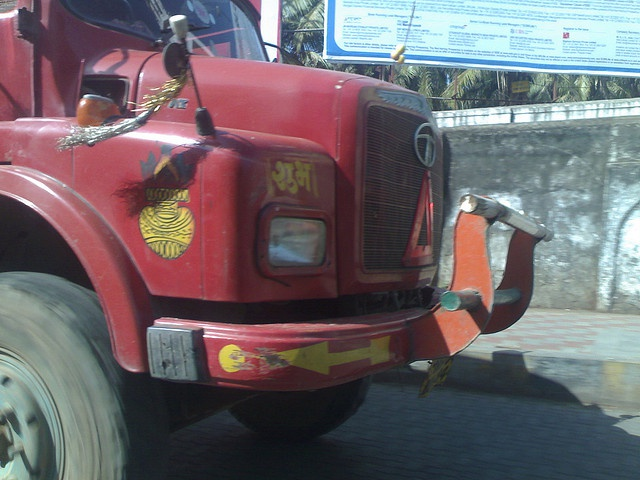Describe the objects in this image and their specific colors. I can see a truck in gray, black, brown, and maroon tones in this image. 